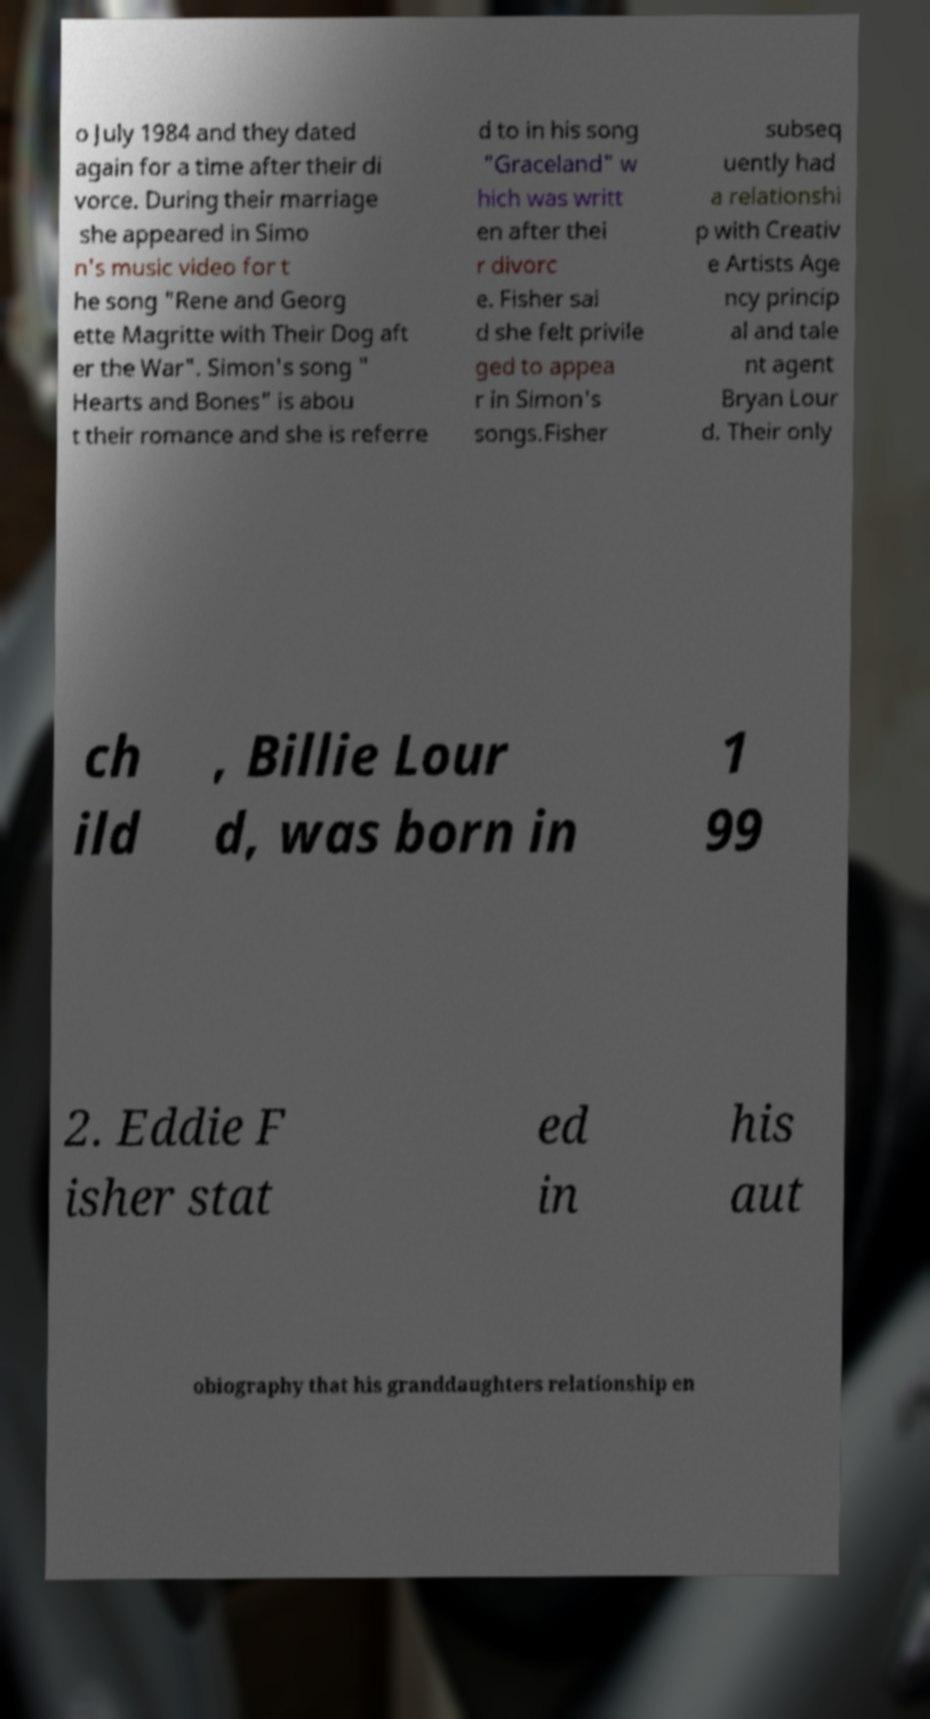Can you accurately transcribe the text from the provided image for me? o July 1984 and they dated again for a time after their di vorce. During their marriage she appeared in Simo n's music video for t he song "Rene and Georg ette Magritte with Their Dog aft er the War". Simon's song " Hearts and Bones" is abou t their romance and she is referre d to in his song "Graceland" w hich was writt en after thei r divorc e. Fisher sai d she felt privile ged to appea r in Simon's songs.Fisher subseq uently had a relationshi p with Creativ e Artists Age ncy princip al and tale nt agent Bryan Lour d. Their only ch ild , Billie Lour d, was born in 1 99 2. Eddie F isher stat ed in his aut obiography that his granddaughters relationship en 